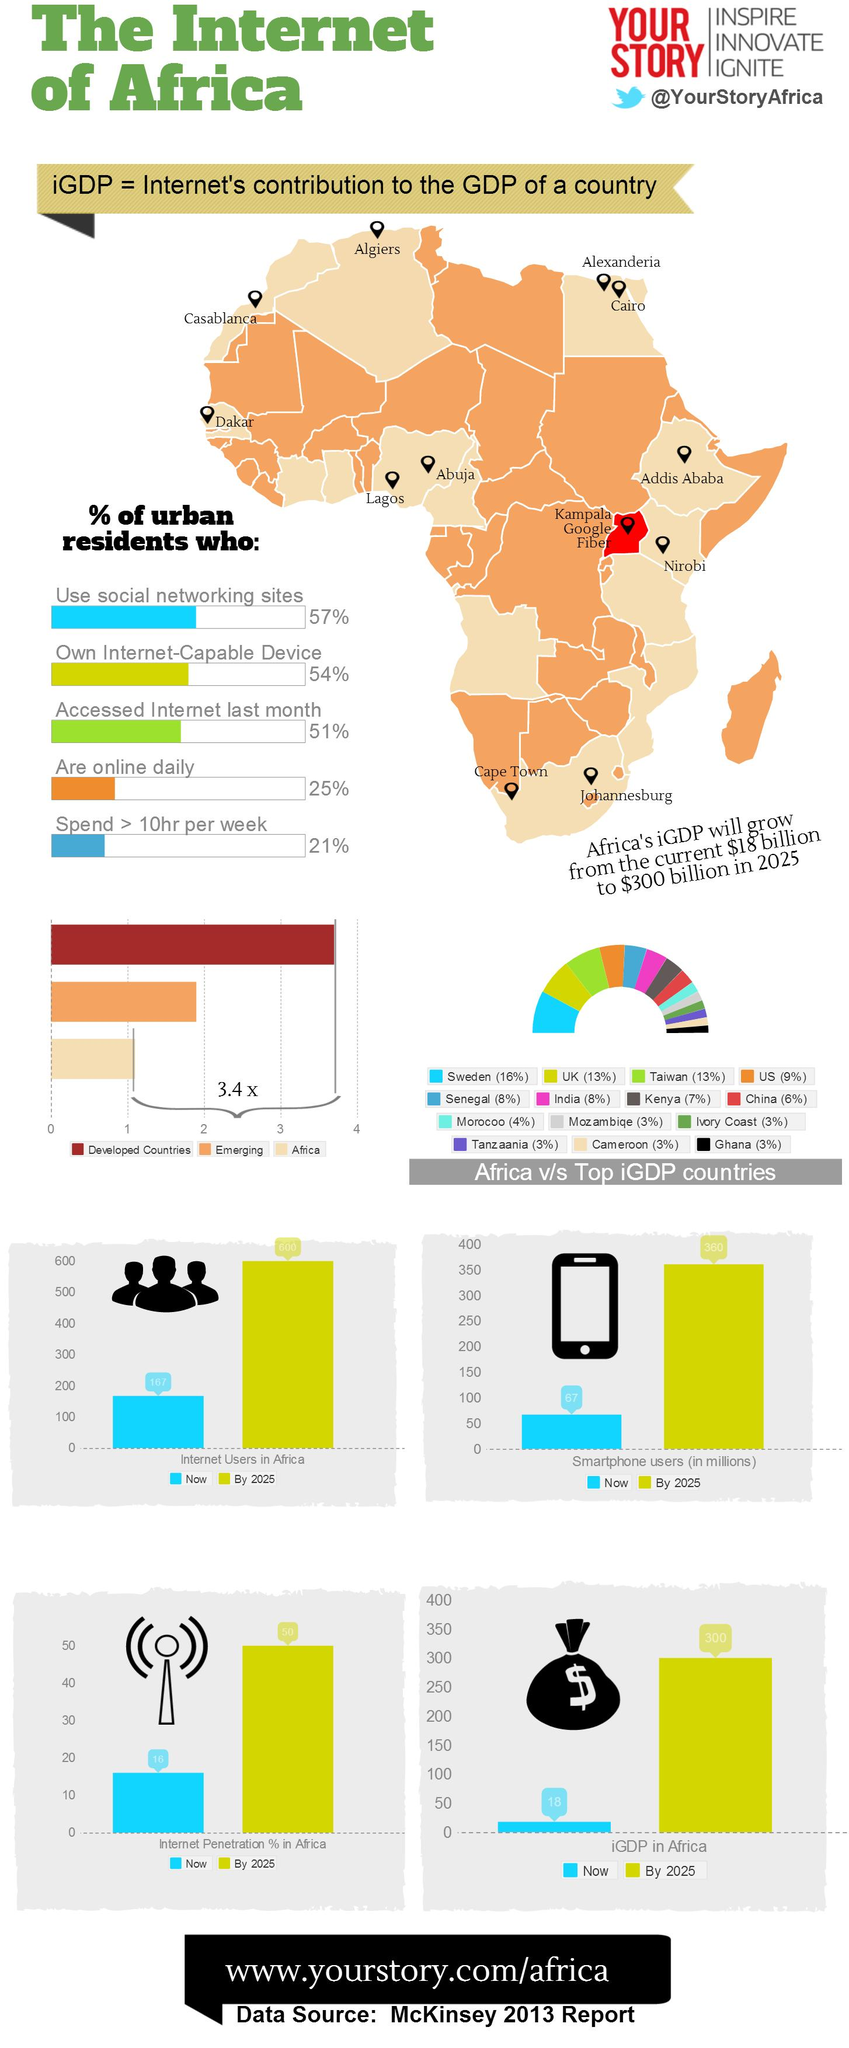Identify some key points in this picture. The iGDP value for India is 8%. By 2025, it is projected that approximately 360 million smartphone users will be present in Africa. The social media handle given here is Twitter, and it is not Facebook or Instagram. The country of Senegal has a GDP (gross domestic product) that is equivalent to that of India. The area in red in the map is written next to Kampala Google Fiber. 